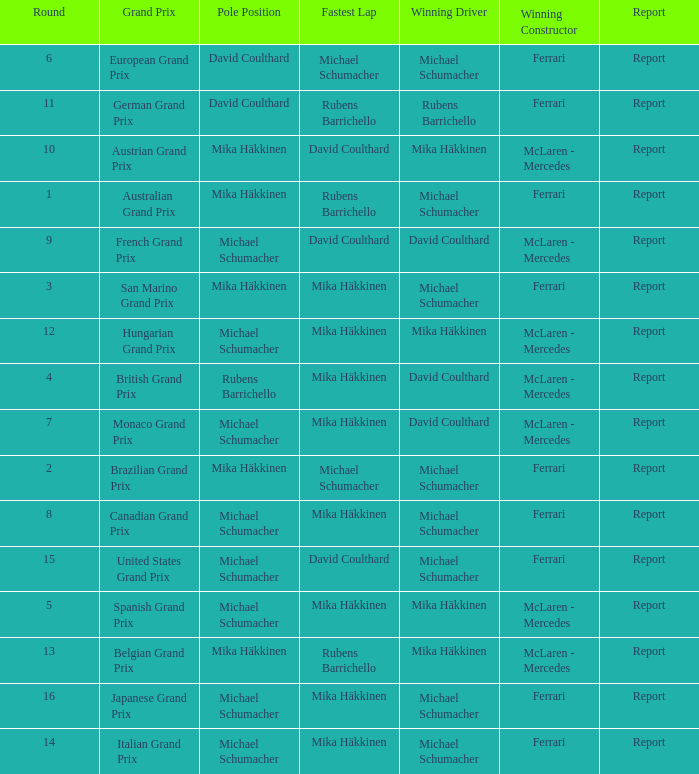Who had the fastest lap in the Belgian Grand Prix? Rubens Barrichello. 